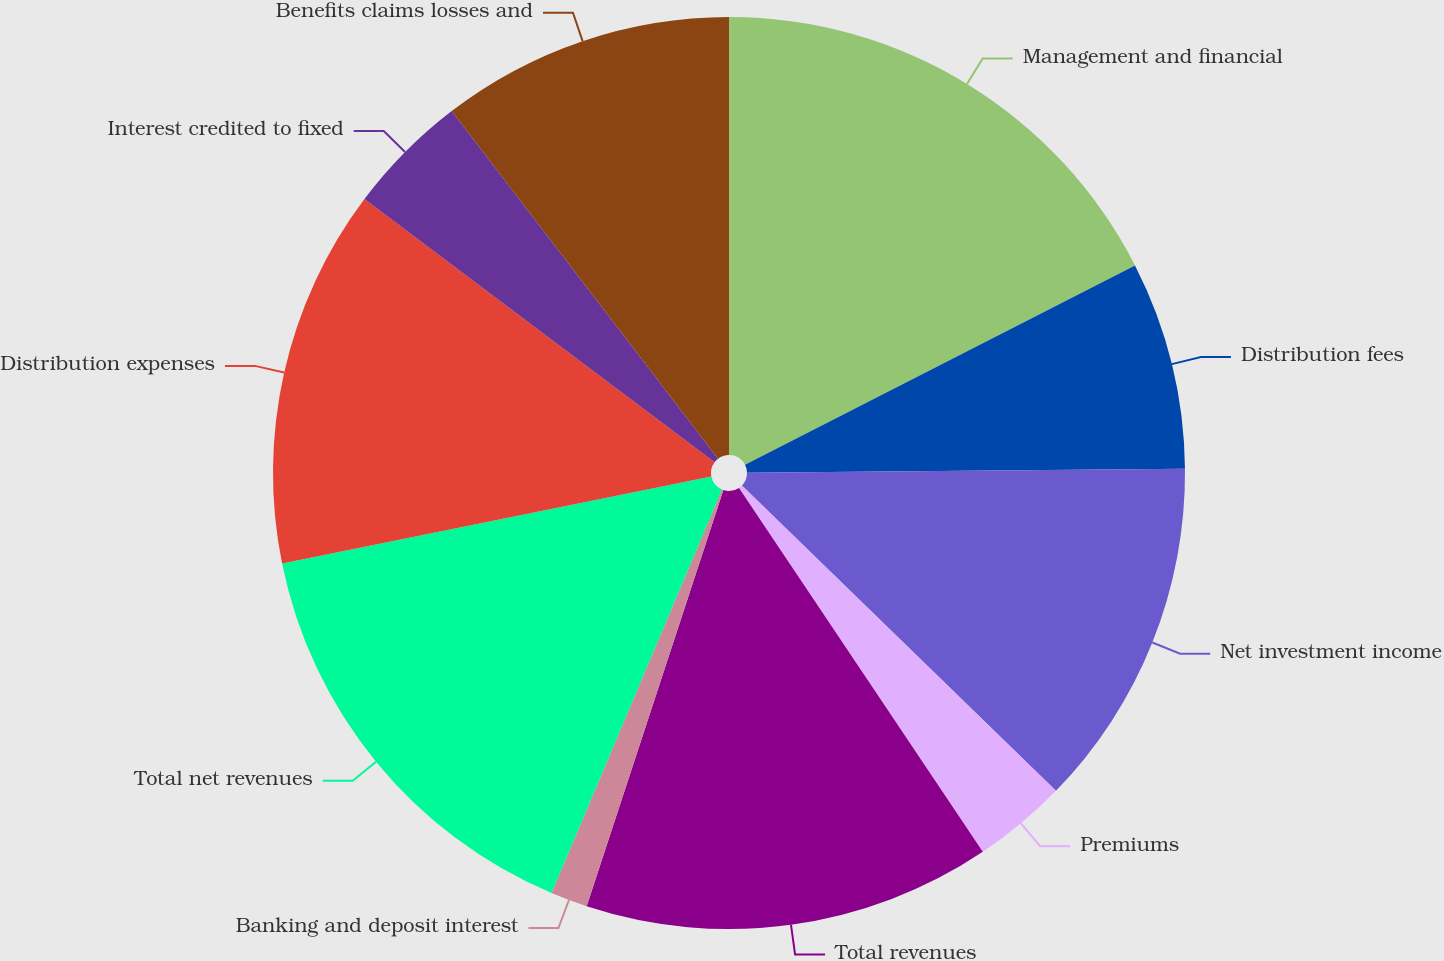Convert chart. <chart><loc_0><loc_0><loc_500><loc_500><pie_chart><fcel>Management and financial<fcel>Distribution fees<fcel>Net investment income<fcel>Premiums<fcel>Total revenues<fcel>Banking and deposit interest<fcel>Total net revenues<fcel>Distribution expenses<fcel>Interest credited to fixed<fcel>Benefits claims losses and<nl><fcel>17.47%<fcel>7.37%<fcel>12.42%<fcel>3.33%<fcel>14.44%<fcel>1.31%<fcel>15.45%<fcel>13.43%<fcel>4.34%<fcel>10.4%<nl></chart> 